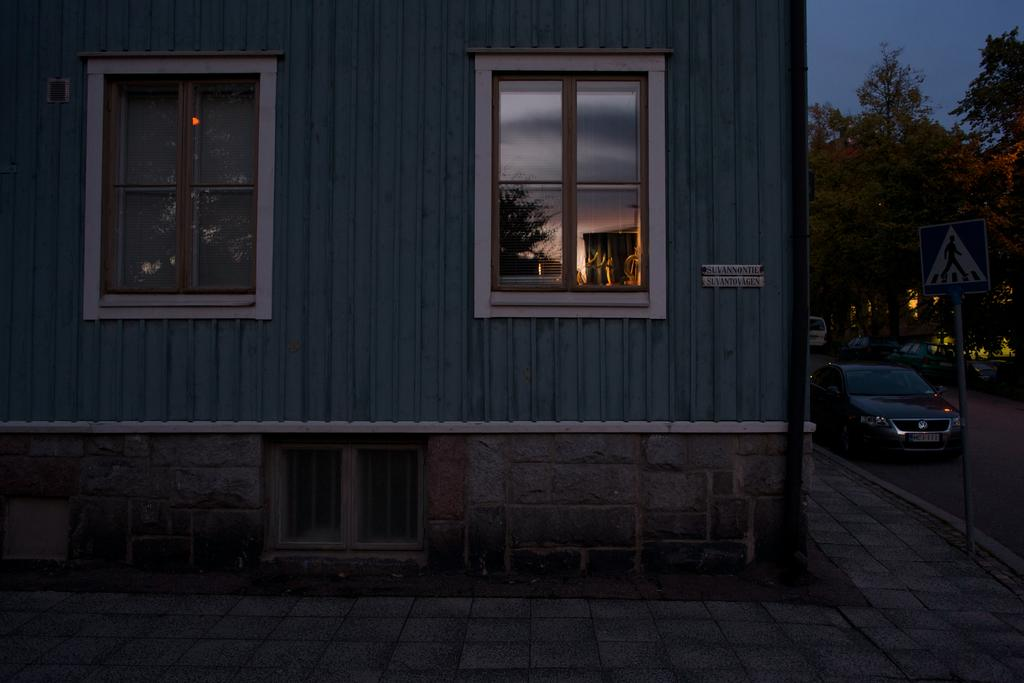What type of path is visible at the bottom of the image? There is a footpath at the bottom of the image. What structure can be seen in the image? There is a building in the image. How many windows are on the building? The building has three windows. What is present on the right side of the image? There are vehicles on the road on the right side of the image. What is the purpose of the sign board in the image? The purpose of the sign board in the image is not specified, but it is likely to provide information or directions. What is the tall, vertical object in the image? There is a pole in the image. What type of vegetation is visible in the image? There are trees in the image. What part of the natural environment is visible in the image? The sky is visible in the image. Can you tell me how many zebras are attacking the building in the image? There are no zebras present in the image, nor is there any indication of an attack on the building. What happens when the sign board smashes into the pole in the image? There is no event of a sign board smashing into the pole in the image. 